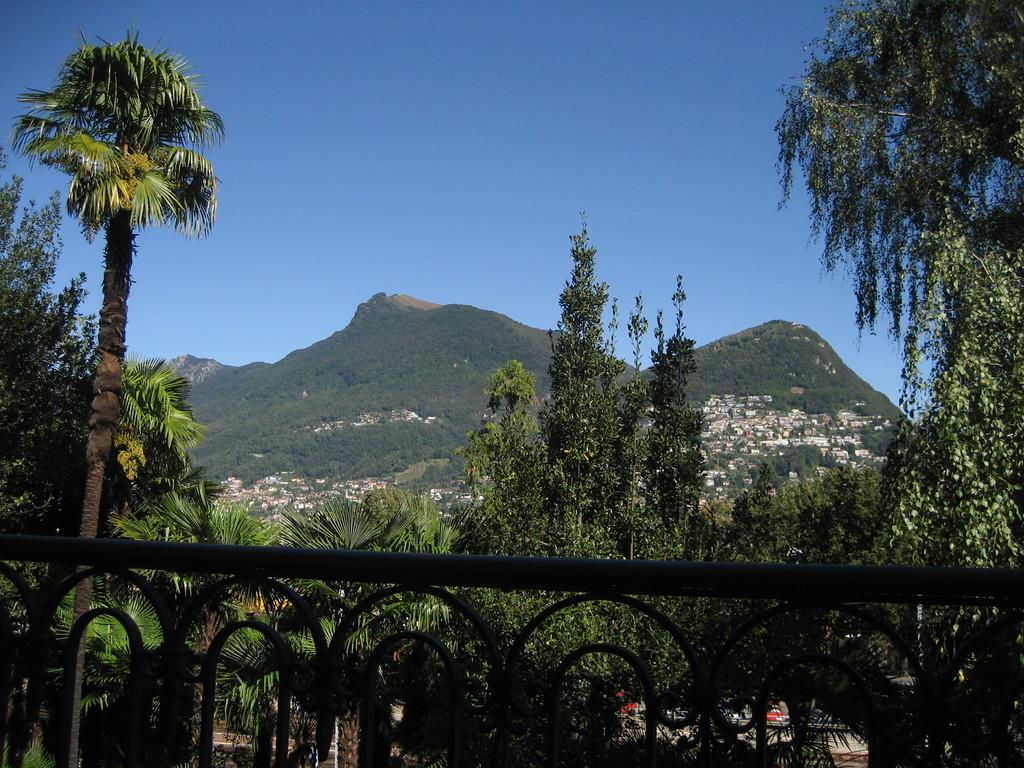What type of objects can be seen in the image? There are metal rods in the image. What natural elements are present in the image? There are trees in the image. What structures can be seen in the background of the image? There are houses in the background of the image. What geographical features are visible in the background of the image? There are hills in the background of the image. What type of food is being distributed in the image? There is no food or distribution activity present in the image. Can you identify any birds in the image? There are no birds visible in the image. 